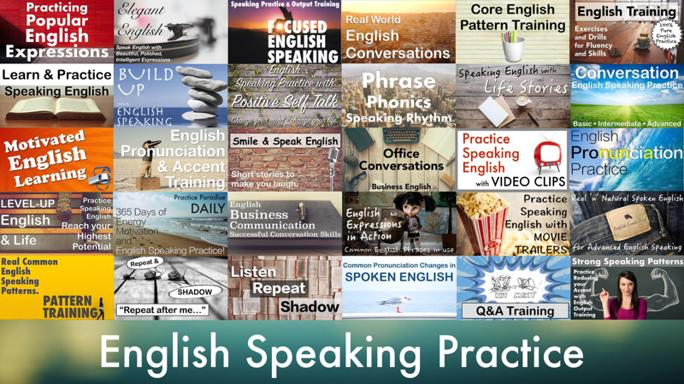What are some of the methods mentioned in the image for improving English speaking? The image highlights a variety of engaging methods to enhance English speaking skills, such as using popular English expressions for real-world practice, engaging in pattern training focusing on phonics and rhythm, and practical applications like daily business conversations and video clip training. It also emphasizes motivational aspects like positive self-talk and continuous practice through practical exercises. 